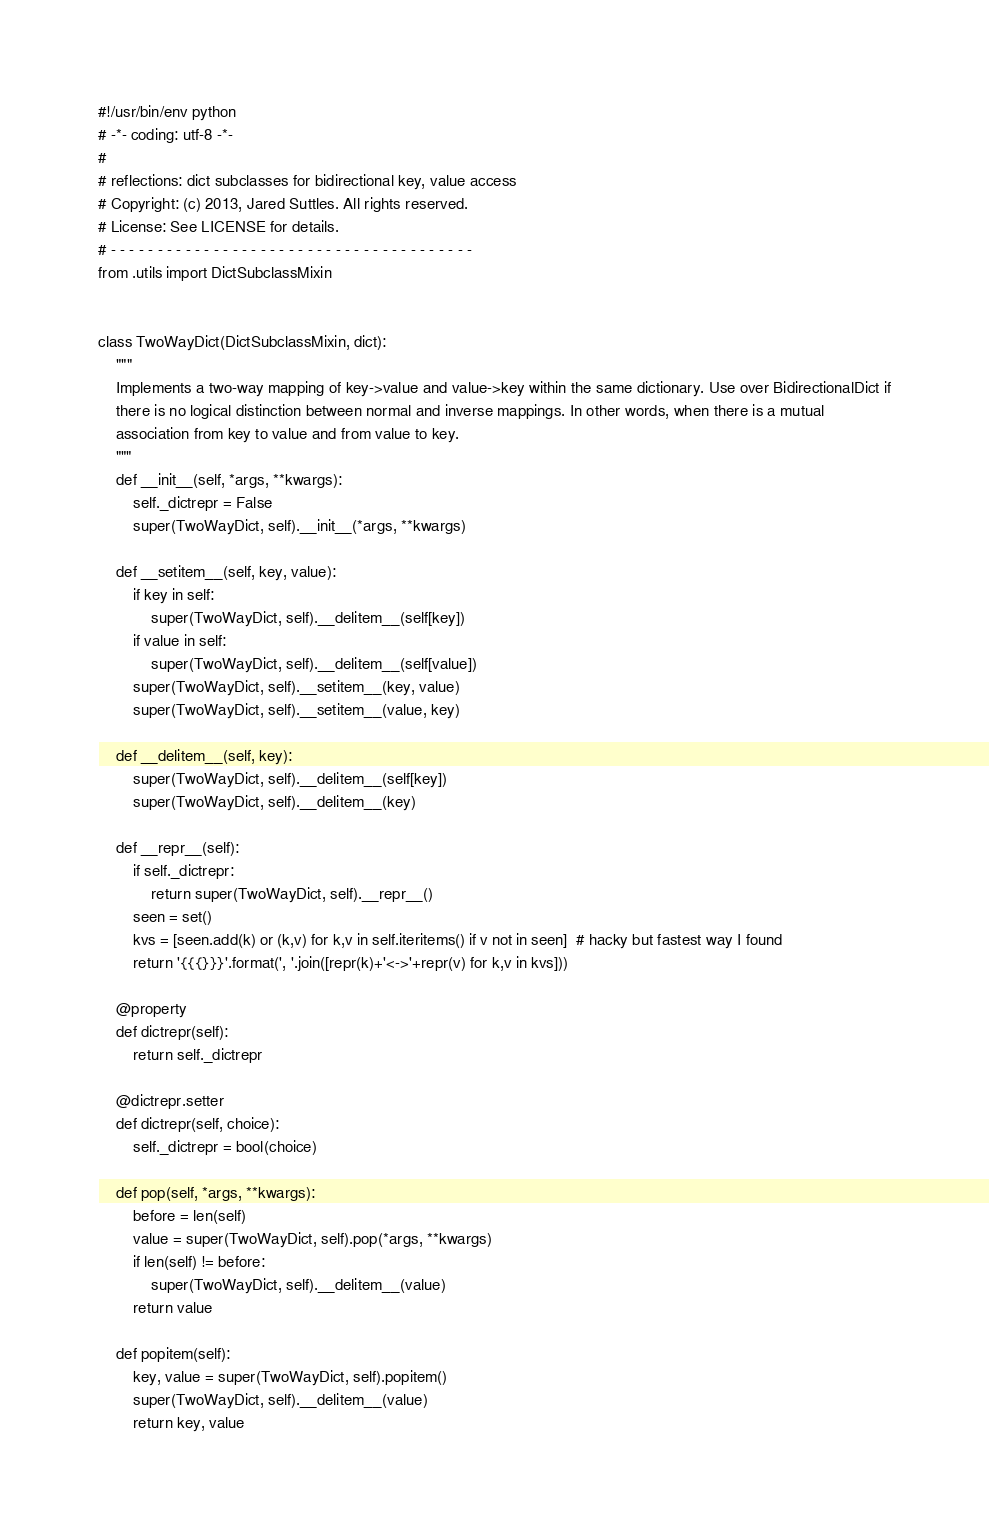<code> <loc_0><loc_0><loc_500><loc_500><_Python_>#!/usr/bin/env python
# -*- coding: utf-8 -*-
#
# reflections: dict subclasses for bidirectional key, value access
# Copyright: (c) 2013, Jared Suttles. All rights reserved.
# License: See LICENSE for details.
# - - - - - - - - - - - - - - - - - - - - - - - - - - - - - - - - - - - - - - -
from .utils import DictSubclassMixin


class TwoWayDict(DictSubclassMixin, dict):
    """
    Implements a two-way mapping of key->value and value->key within the same dictionary. Use over BidirectionalDict if
    there is no logical distinction between normal and inverse mappings. In other words, when there is a mutual
    association from key to value and from value to key.
    """
    def __init__(self, *args, **kwargs):
        self._dictrepr = False
        super(TwoWayDict, self).__init__(*args, **kwargs)

    def __setitem__(self, key, value):
        if key in self:
            super(TwoWayDict, self).__delitem__(self[key])
        if value in self:
            super(TwoWayDict, self).__delitem__(self[value])
        super(TwoWayDict, self).__setitem__(key, value)
        super(TwoWayDict, self).__setitem__(value, key)

    def __delitem__(self, key):
        super(TwoWayDict, self).__delitem__(self[key])
        super(TwoWayDict, self).__delitem__(key)

    def __repr__(self):
        if self._dictrepr:
            return super(TwoWayDict, self).__repr__()
        seen = set()
        kvs = [seen.add(k) or (k,v) for k,v in self.iteritems() if v not in seen]  # hacky but fastest way I found
        return '{{{}}}'.format(', '.join([repr(k)+'<->'+repr(v) for k,v in kvs]))

    @property
    def dictrepr(self):
        return self._dictrepr

    @dictrepr.setter
    def dictrepr(self, choice):
        self._dictrepr = bool(choice)

    def pop(self, *args, **kwargs):
        before = len(self)
        value = super(TwoWayDict, self).pop(*args, **kwargs)
        if len(self) != before:
            super(TwoWayDict, self).__delitem__(value)
        return value

    def popitem(self):
        key, value = super(TwoWayDict, self).popitem()
        super(TwoWayDict, self).__delitem__(value)
        return key, value
</code> 